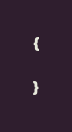Convert code to text. <code><loc_0><loc_0><loc_500><loc_500><_C++_>{

}
</code> 